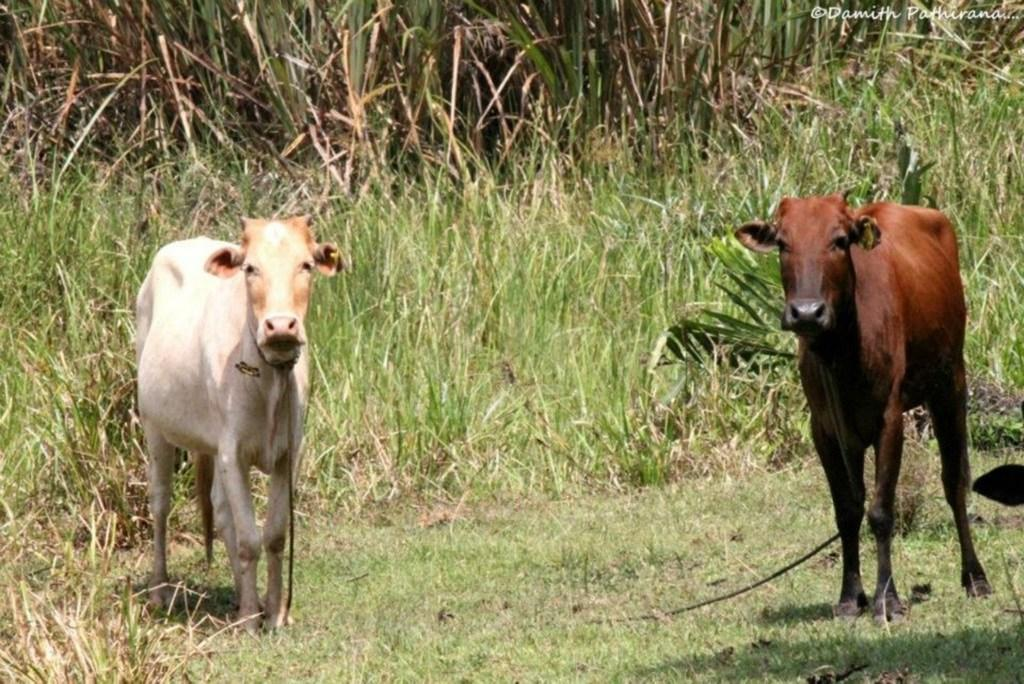How many cows are in the image? There are two cows in the image. What can be seen in the background of the image? There are green plants in the background of the image. What object is visible in the image that could be used for tying or leading? There is a rope visible in the image. What arithmetic problem can be solved using the cows in the image? There is no arithmetic problem present in the image, as it features two cows and a background of green plants. 